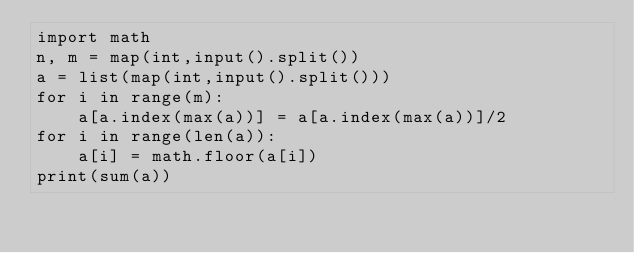<code> <loc_0><loc_0><loc_500><loc_500><_Python_>import math
n, m = map(int,input().split())
a = list(map(int,input().split()))
for i in range(m):
    a[a.index(max(a))] = a[a.index(max(a))]/2
for i in range(len(a)):
    a[i] = math.floor(a[i])
print(sum(a))</code> 